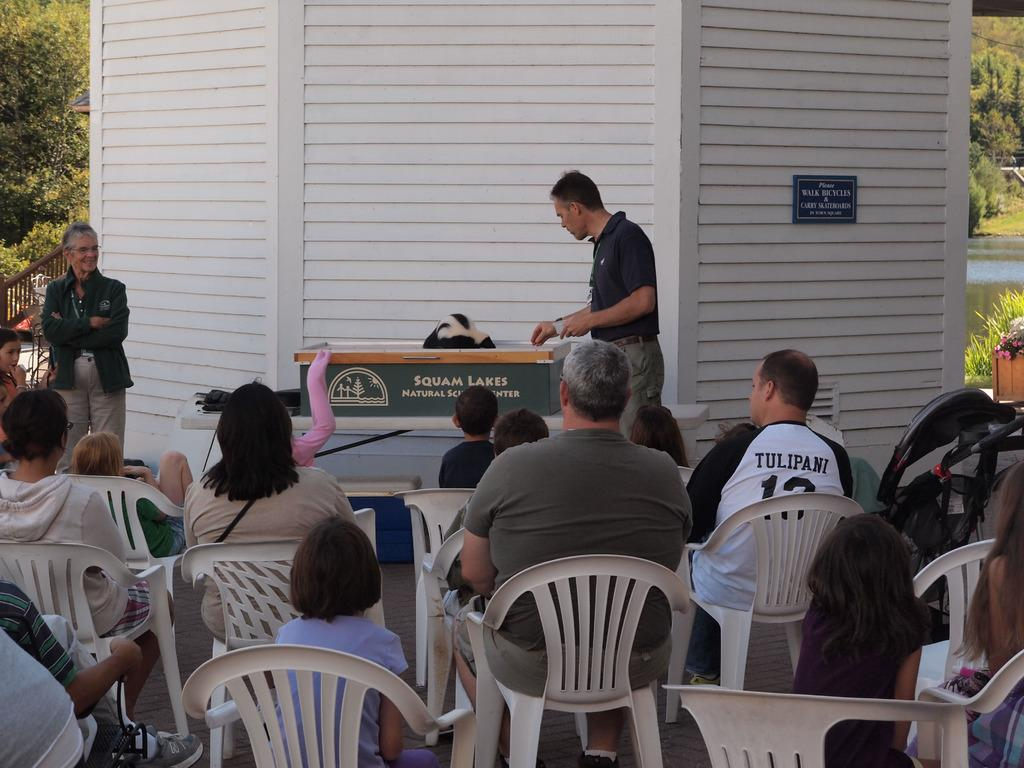<image>
Share a concise interpretation of the image provided. A man stands in front of a sign that says Squam Lakes. 